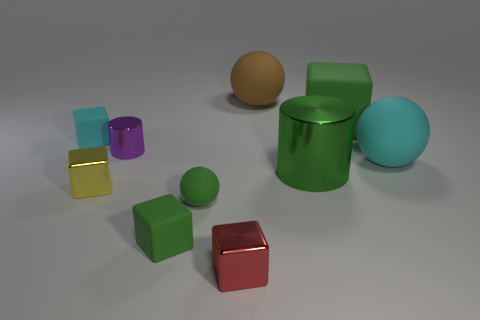Can you describe the different materials and textures visible among the objects? Certainly! The scene showcases a variety of materials, each with distinct textures. For example, you can observe the rubbery surfaces of both the green sphere and the cube, hinted by their matte finishes and soft reflections. In stark contrast, the yellow metallic object has a shiny, reflective surface that vividly catches the light, typical of metallic textures. The cyan matte object, on the other hand, exhibits a dull, non-shiny surface that diffuses light, indicative of a non-metallic, perhaps plastic or painted material. 